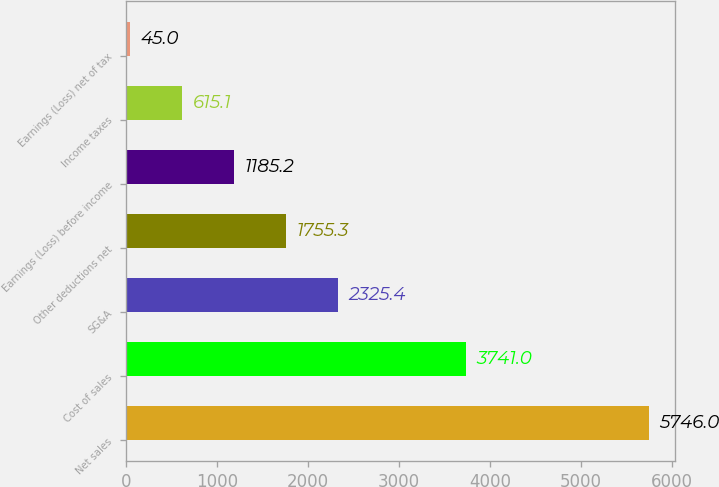Convert chart. <chart><loc_0><loc_0><loc_500><loc_500><bar_chart><fcel>Net sales<fcel>Cost of sales<fcel>SG&A<fcel>Other deductions net<fcel>Earnings (Loss) before income<fcel>Income taxes<fcel>Earnings (Loss) net of tax<nl><fcel>5746<fcel>3741<fcel>2325.4<fcel>1755.3<fcel>1185.2<fcel>615.1<fcel>45<nl></chart> 